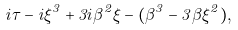<formula> <loc_0><loc_0><loc_500><loc_500>i \tau - i \xi ^ { 3 } + 3 i \beta ^ { 2 } \xi - ( \beta ^ { 3 } - 3 \beta \xi ^ { 2 } ) ,</formula> 